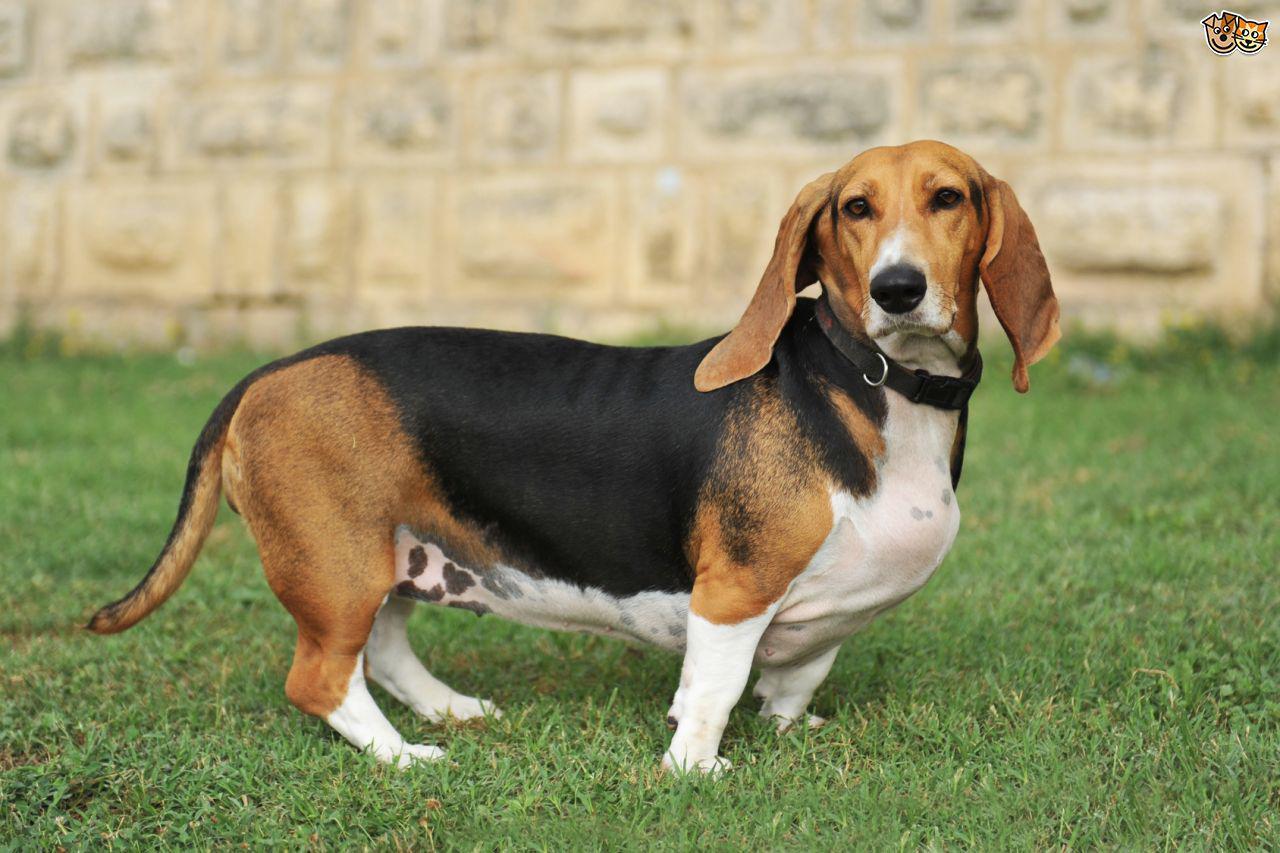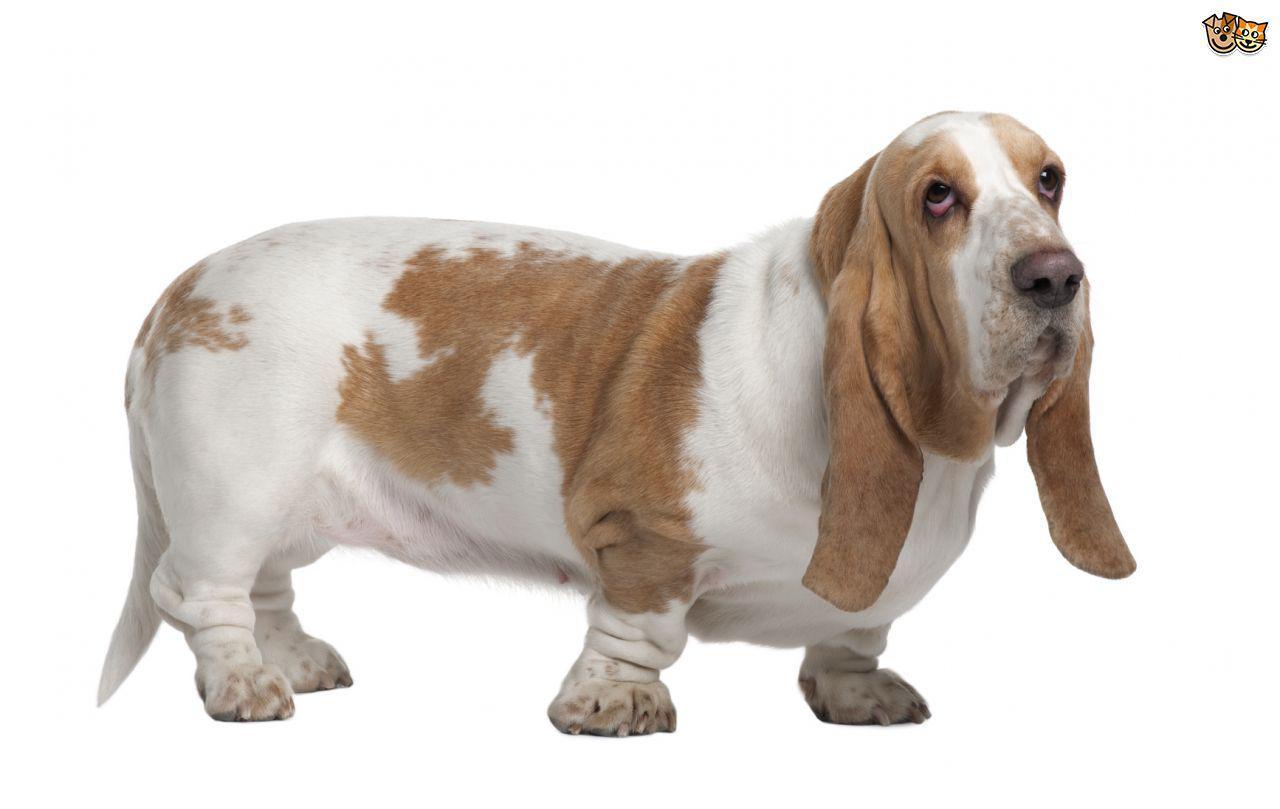The first image is the image on the left, the second image is the image on the right. Considering the images on both sides, is "In one of the images there is a basset hound puppy sitting." valid? Answer yes or no. No. 